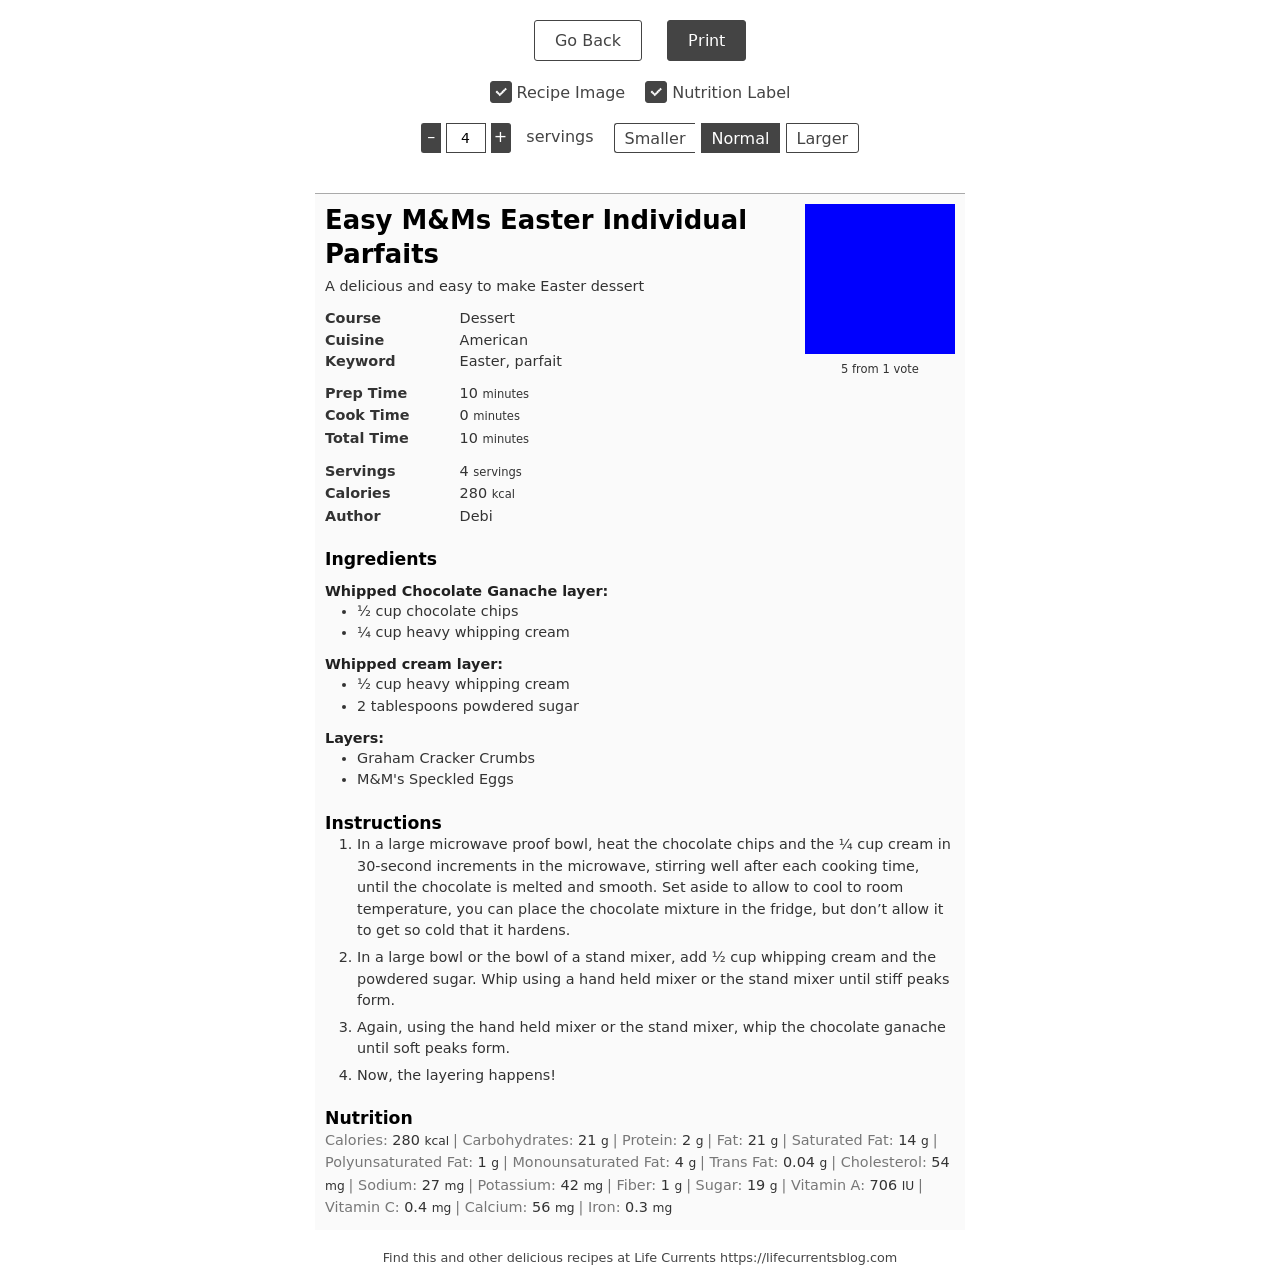What ingredients are needed for the chocolate ganache layer in this dessert? The chocolate ganache layer requires ½ cup of chocolate chips and ¼ cup of heavy whipping cream. You'll need to heat these ingredients together and mix until smooth. 